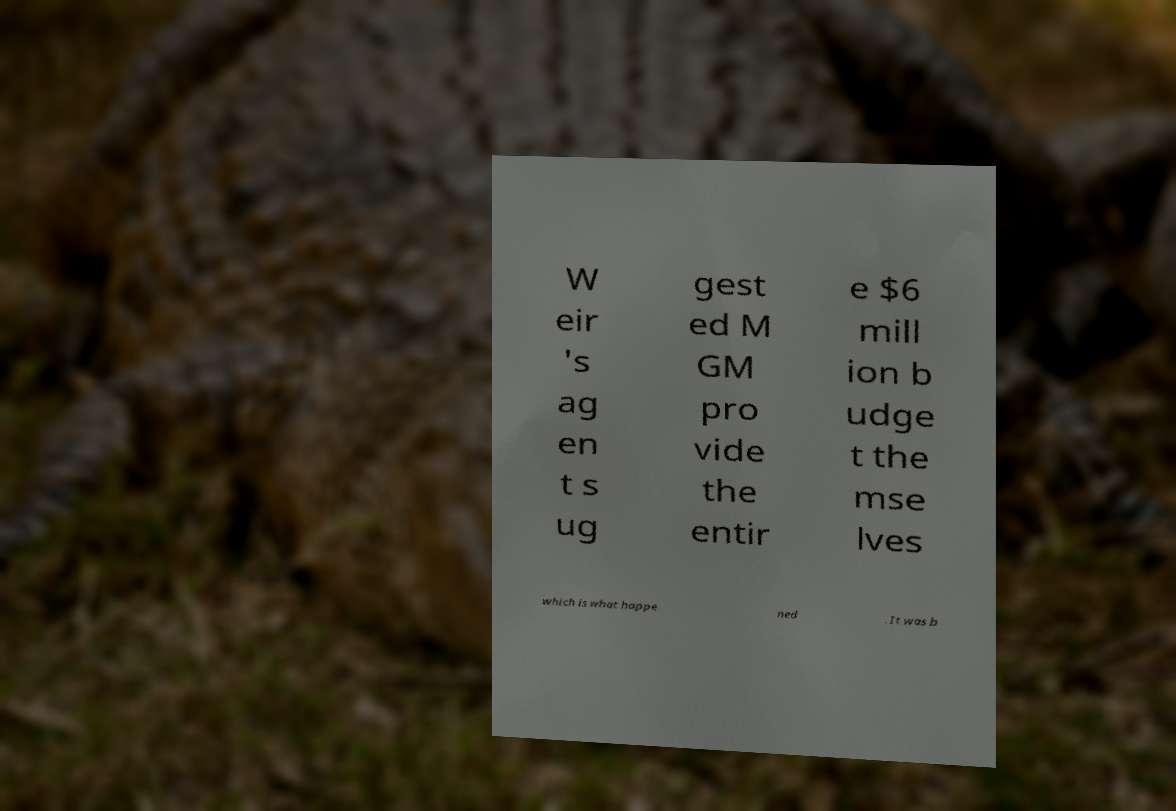Could you assist in decoding the text presented in this image and type it out clearly? W eir 's ag en t s ug gest ed M GM pro vide the entir e $6 mill ion b udge t the mse lves which is what happe ned . It was b 